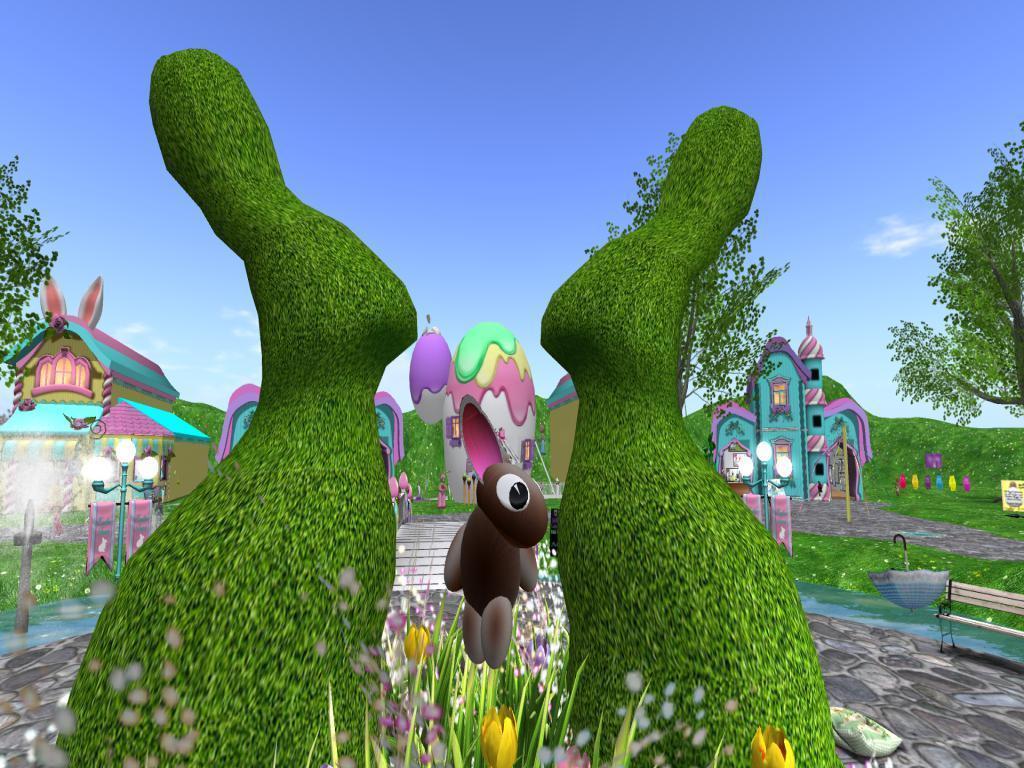Describe this image in one or two sentences. This picture is consists of an animated picture in the image, in which there are doll houses and greenery in the image. 